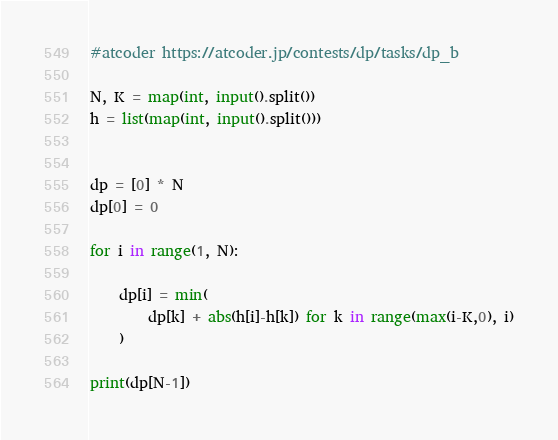Convert code to text. <code><loc_0><loc_0><loc_500><loc_500><_Python_>#atcoder https://atcoder.jp/contests/dp/tasks/dp_b

N, K = map(int, input().split())
h = list(map(int, input().split()))


dp = [0] * N
dp[0] = 0

for i in range(1, N):

    dp[i] = min(
        dp[k] + abs(h[i]-h[k]) for k in range(max(i-K,0), i)
    )

print(dp[N-1])
</code> 